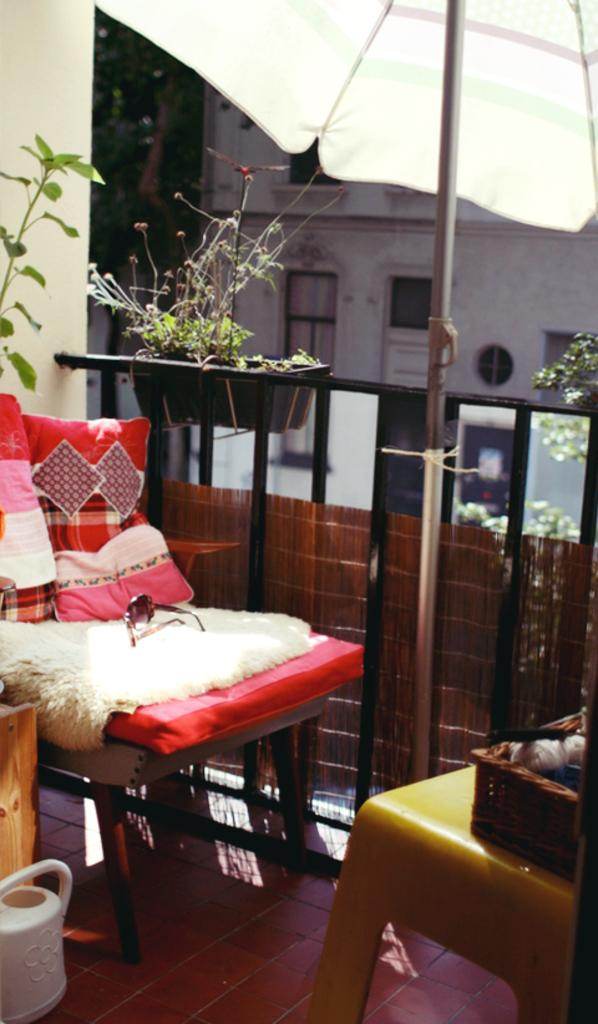What type of furniture is in the image? There is a chair in the image. What is unique about the chair? The chair has goggles on it. What can be seen in the background of the image? There are trees and a building in the background of the image. What type of duck is sitting on the coach in the image? There is no duck or coach present in the image. 